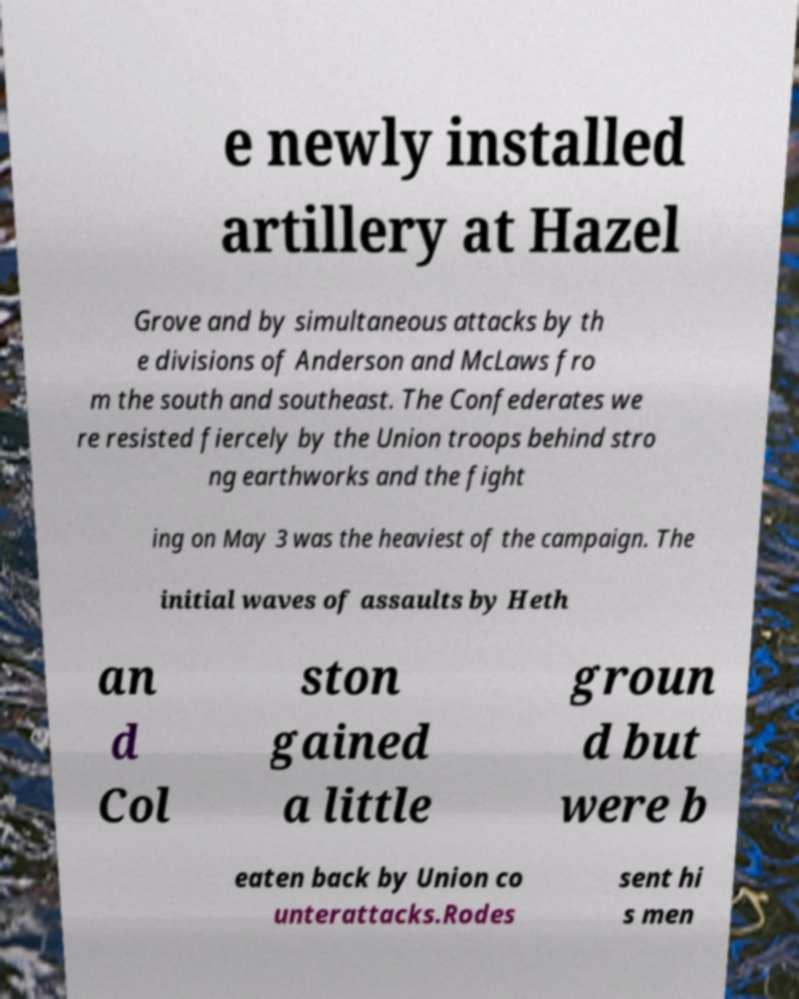Could you assist in decoding the text presented in this image and type it out clearly? e newly installed artillery at Hazel Grove and by simultaneous attacks by th e divisions of Anderson and McLaws fro m the south and southeast. The Confederates we re resisted fiercely by the Union troops behind stro ng earthworks and the fight ing on May 3 was the heaviest of the campaign. The initial waves of assaults by Heth an d Col ston gained a little groun d but were b eaten back by Union co unterattacks.Rodes sent hi s men 